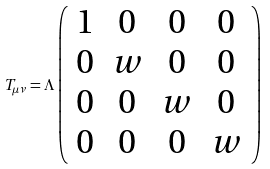Convert formula to latex. <formula><loc_0><loc_0><loc_500><loc_500>T _ { \mu \nu } = \Lambda \left ( \begin{array} { c c c c } 1 & 0 & 0 & 0 \\ 0 & w & 0 & 0 \\ 0 & 0 & w & 0 \\ 0 & 0 & 0 & w \end{array} \right )</formula> 